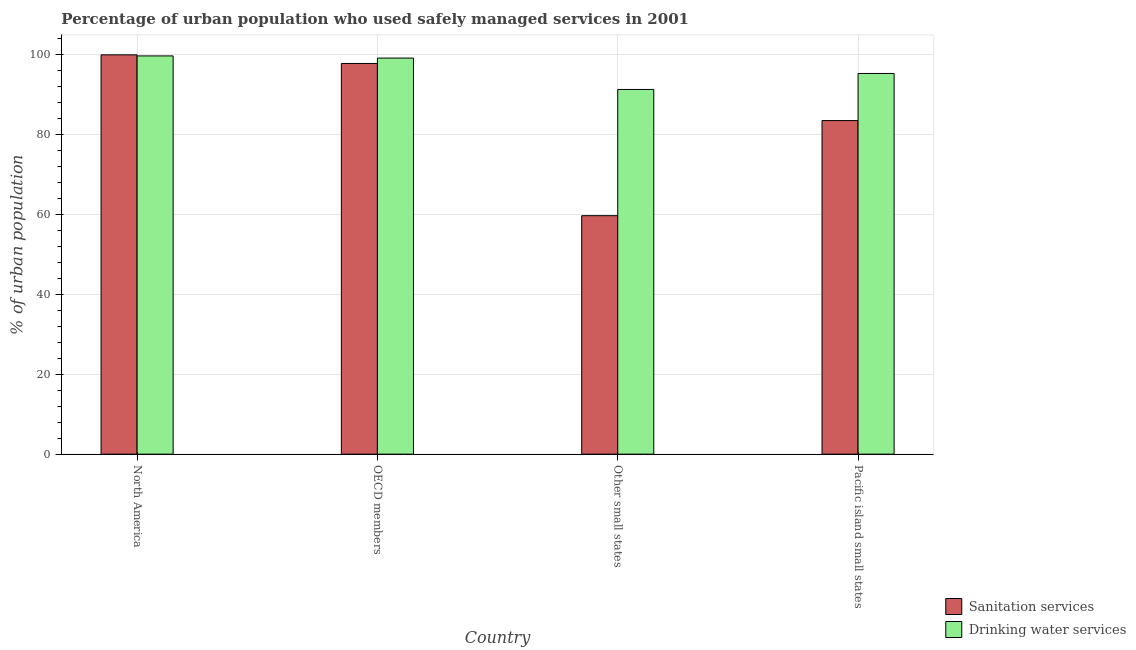How many different coloured bars are there?
Ensure brevity in your answer.  2. Are the number of bars per tick equal to the number of legend labels?
Provide a succinct answer. Yes. Are the number of bars on each tick of the X-axis equal?
Give a very brief answer. Yes. How many bars are there on the 3rd tick from the left?
Give a very brief answer. 2. What is the label of the 4th group of bars from the left?
Ensure brevity in your answer.  Pacific island small states. In how many cases, is the number of bars for a given country not equal to the number of legend labels?
Your answer should be very brief. 0. What is the percentage of urban population who used sanitation services in Other small states?
Keep it short and to the point. 59.67. Across all countries, what is the maximum percentage of urban population who used sanitation services?
Ensure brevity in your answer.  99.91. Across all countries, what is the minimum percentage of urban population who used sanitation services?
Keep it short and to the point. 59.67. In which country was the percentage of urban population who used sanitation services maximum?
Keep it short and to the point. North America. In which country was the percentage of urban population who used drinking water services minimum?
Provide a succinct answer. Other small states. What is the total percentage of urban population who used sanitation services in the graph?
Keep it short and to the point. 340.8. What is the difference between the percentage of urban population who used sanitation services in North America and that in OECD members?
Provide a succinct answer. 2.16. What is the difference between the percentage of urban population who used sanitation services in Pacific island small states and the percentage of urban population who used drinking water services in North America?
Your answer should be very brief. -16.18. What is the average percentage of urban population who used drinking water services per country?
Offer a terse response. 96.31. What is the difference between the percentage of urban population who used sanitation services and percentage of urban population who used drinking water services in North America?
Give a very brief answer. 0.27. What is the ratio of the percentage of urban population who used sanitation services in Other small states to that in Pacific island small states?
Keep it short and to the point. 0.71. Is the percentage of urban population who used sanitation services in North America less than that in Pacific island small states?
Keep it short and to the point. No. Is the difference between the percentage of urban population who used sanitation services in North America and OECD members greater than the difference between the percentage of urban population who used drinking water services in North America and OECD members?
Keep it short and to the point. Yes. What is the difference between the highest and the second highest percentage of urban population who used drinking water services?
Provide a short and direct response. 0.54. What is the difference between the highest and the lowest percentage of urban population who used sanitation services?
Your response must be concise. 40.24. What does the 1st bar from the left in North America represents?
Provide a succinct answer. Sanitation services. What does the 2nd bar from the right in OECD members represents?
Keep it short and to the point. Sanitation services. How many bars are there?
Offer a terse response. 8. How many countries are there in the graph?
Give a very brief answer. 4. Does the graph contain any zero values?
Make the answer very short. No. Where does the legend appear in the graph?
Keep it short and to the point. Bottom right. How many legend labels are there?
Offer a very short reply. 2. What is the title of the graph?
Ensure brevity in your answer.  Percentage of urban population who used safely managed services in 2001. What is the label or title of the Y-axis?
Provide a succinct answer. % of urban population. What is the % of urban population in Sanitation services in North America?
Ensure brevity in your answer.  99.91. What is the % of urban population in Drinking water services in North America?
Your answer should be very brief. 99.64. What is the % of urban population of Sanitation services in OECD members?
Offer a very short reply. 97.75. What is the % of urban population of Drinking water services in OECD members?
Keep it short and to the point. 99.1. What is the % of urban population in Sanitation services in Other small states?
Offer a terse response. 59.67. What is the % of urban population of Drinking water services in Other small states?
Make the answer very short. 91.25. What is the % of urban population of Sanitation services in Pacific island small states?
Provide a short and direct response. 83.46. What is the % of urban population in Drinking water services in Pacific island small states?
Your answer should be very brief. 95.25. Across all countries, what is the maximum % of urban population of Sanitation services?
Ensure brevity in your answer.  99.91. Across all countries, what is the maximum % of urban population of Drinking water services?
Make the answer very short. 99.64. Across all countries, what is the minimum % of urban population of Sanitation services?
Your response must be concise. 59.67. Across all countries, what is the minimum % of urban population of Drinking water services?
Your response must be concise. 91.25. What is the total % of urban population in Sanitation services in the graph?
Make the answer very short. 340.8. What is the total % of urban population of Drinking water services in the graph?
Make the answer very short. 385.24. What is the difference between the % of urban population in Sanitation services in North America and that in OECD members?
Offer a terse response. 2.16. What is the difference between the % of urban population of Drinking water services in North America and that in OECD members?
Keep it short and to the point. 0.54. What is the difference between the % of urban population in Sanitation services in North America and that in Other small states?
Your response must be concise. 40.24. What is the difference between the % of urban population in Drinking water services in North America and that in Other small states?
Your answer should be compact. 8.39. What is the difference between the % of urban population in Sanitation services in North America and that in Pacific island small states?
Make the answer very short. 16.45. What is the difference between the % of urban population in Drinking water services in North America and that in Pacific island small states?
Ensure brevity in your answer.  4.39. What is the difference between the % of urban population of Sanitation services in OECD members and that in Other small states?
Your answer should be compact. 38.08. What is the difference between the % of urban population in Drinking water services in OECD members and that in Other small states?
Offer a very short reply. 7.85. What is the difference between the % of urban population of Sanitation services in OECD members and that in Pacific island small states?
Make the answer very short. 14.29. What is the difference between the % of urban population in Drinking water services in OECD members and that in Pacific island small states?
Your answer should be compact. 3.85. What is the difference between the % of urban population in Sanitation services in Other small states and that in Pacific island small states?
Keep it short and to the point. -23.79. What is the difference between the % of urban population in Drinking water services in Other small states and that in Pacific island small states?
Offer a terse response. -4. What is the difference between the % of urban population in Sanitation services in North America and the % of urban population in Drinking water services in OECD members?
Your answer should be very brief. 0.81. What is the difference between the % of urban population in Sanitation services in North America and the % of urban population in Drinking water services in Other small states?
Ensure brevity in your answer.  8.66. What is the difference between the % of urban population of Sanitation services in North America and the % of urban population of Drinking water services in Pacific island small states?
Provide a short and direct response. 4.66. What is the difference between the % of urban population in Sanitation services in OECD members and the % of urban population in Drinking water services in Other small states?
Your response must be concise. 6.5. What is the difference between the % of urban population of Sanitation services in OECD members and the % of urban population of Drinking water services in Pacific island small states?
Your response must be concise. 2.5. What is the difference between the % of urban population in Sanitation services in Other small states and the % of urban population in Drinking water services in Pacific island small states?
Offer a very short reply. -35.58. What is the average % of urban population in Sanitation services per country?
Keep it short and to the point. 85.2. What is the average % of urban population of Drinking water services per country?
Your answer should be very brief. 96.31. What is the difference between the % of urban population in Sanitation services and % of urban population in Drinking water services in North America?
Your answer should be compact. 0.27. What is the difference between the % of urban population of Sanitation services and % of urban population of Drinking water services in OECD members?
Give a very brief answer. -1.35. What is the difference between the % of urban population of Sanitation services and % of urban population of Drinking water services in Other small states?
Offer a terse response. -31.58. What is the difference between the % of urban population in Sanitation services and % of urban population in Drinking water services in Pacific island small states?
Offer a terse response. -11.79. What is the ratio of the % of urban population of Sanitation services in North America to that in OECD members?
Your answer should be compact. 1.02. What is the ratio of the % of urban population in Sanitation services in North America to that in Other small states?
Provide a succinct answer. 1.67. What is the ratio of the % of urban population in Drinking water services in North America to that in Other small states?
Offer a terse response. 1.09. What is the ratio of the % of urban population of Sanitation services in North America to that in Pacific island small states?
Offer a very short reply. 1.2. What is the ratio of the % of urban population of Drinking water services in North America to that in Pacific island small states?
Keep it short and to the point. 1.05. What is the ratio of the % of urban population in Sanitation services in OECD members to that in Other small states?
Your response must be concise. 1.64. What is the ratio of the % of urban population of Drinking water services in OECD members to that in Other small states?
Keep it short and to the point. 1.09. What is the ratio of the % of urban population in Sanitation services in OECD members to that in Pacific island small states?
Your answer should be very brief. 1.17. What is the ratio of the % of urban population of Drinking water services in OECD members to that in Pacific island small states?
Offer a terse response. 1.04. What is the ratio of the % of urban population in Sanitation services in Other small states to that in Pacific island small states?
Keep it short and to the point. 0.71. What is the ratio of the % of urban population of Drinking water services in Other small states to that in Pacific island small states?
Your response must be concise. 0.96. What is the difference between the highest and the second highest % of urban population of Sanitation services?
Make the answer very short. 2.16. What is the difference between the highest and the second highest % of urban population in Drinking water services?
Your answer should be compact. 0.54. What is the difference between the highest and the lowest % of urban population in Sanitation services?
Keep it short and to the point. 40.24. What is the difference between the highest and the lowest % of urban population in Drinking water services?
Ensure brevity in your answer.  8.39. 